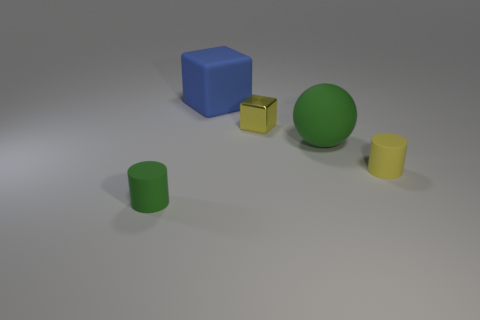Are there the same number of large blue rubber blocks in front of the small yellow shiny block and big balls in front of the large green matte object?
Offer a very short reply. Yes. There is a matte object that is in front of the rubber sphere and on the right side of the small shiny object; what is its shape?
Offer a terse response. Cylinder. There is a tiny green object; how many big green rubber objects are left of it?
Make the answer very short. 0. How many other objects are the same shape as the large blue object?
Your response must be concise. 1. Are there fewer small metal blocks than big yellow things?
Offer a very short reply. No. What size is the object that is both in front of the yellow metallic thing and behind the yellow rubber cylinder?
Offer a terse response. Large. There is a green thing that is in front of the green rubber object that is behind the tiny matte cylinder that is on the left side of the yellow rubber object; what is its size?
Ensure brevity in your answer.  Small. The green sphere is what size?
Ensure brevity in your answer.  Large. Is there anything else that has the same material as the blue object?
Provide a succinct answer. Yes. There is a small yellow thing that is behind the tiny cylinder that is on the right side of the large green rubber sphere; is there a tiny yellow matte thing behind it?
Keep it short and to the point. No. 